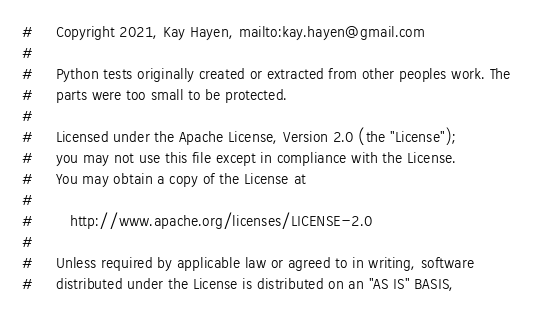<code> <loc_0><loc_0><loc_500><loc_500><_Python_>#     Copyright 2021, Kay Hayen, mailto:kay.hayen@gmail.com
#
#     Python tests originally created or extracted from other peoples work. The
#     parts were too small to be protected.
#
#     Licensed under the Apache License, Version 2.0 (the "License");
#     you may not use this file except in compliance with the License.
#     You may obtain a copy of the License at
#
#        http://www.apache.org/licenses/LICENSE-2.0
#
#     Unless required by applicable law or agreed to in writing, software
#     distributed under the License is distributed on an "AS IS" BASIS,</code> 